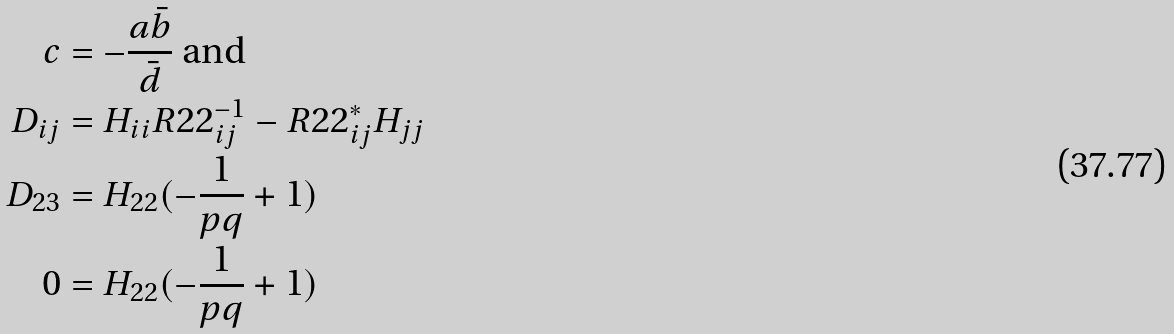<formula> <loc_0><loc_0><loc_500><loc_500>c & = - \frac { a \bar { b } } { \bar { d } } \text { and} \\ D _ { i j } & = H _ { i i } R 2 2 ^ { - 1 } _ { i j } - R 2 2 ^ { * } _ { i j } H _ { j j } \\ D _ { 2 3 } & = H _ { 2 2 } ( - \frac { 1 } { p q } + 1 ) \\ 0 & = H _ { 2 2 } ( - \frac { 1 } { p q } + 1 )</formula> 